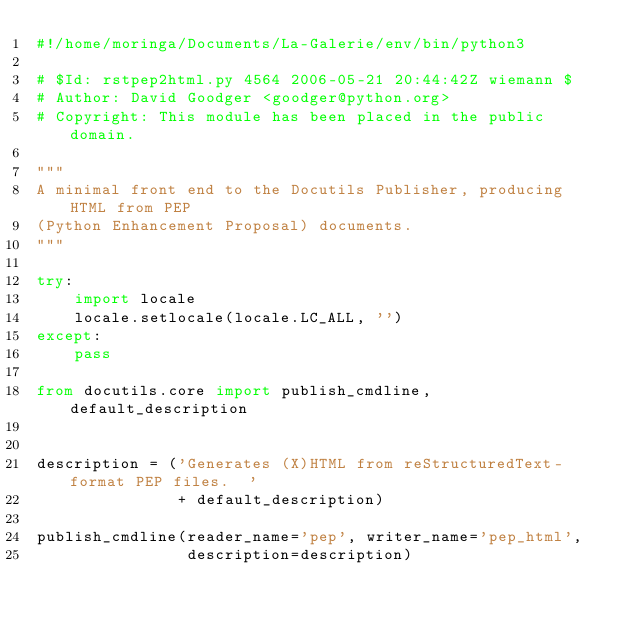Convert code to text. <code><loc_0><loc_0><loc_500><loc_500><_Python_>#!/home/moringa/Documents/La-Galerie/env/bin/python3

# $Id: rstpep2html.py 4564 2006-05-21 20:44:42Z wiemann $
# Author: David Goodger <goodger@python.org>
# Copyright: This module has been placed in the public domain.

"""
A minimal front end to the Docutils Publisher, producing HTML from PEP
(Python Enhancement Proposal) documents.
"""

try:
    import locale
    locale.setlocale(locale.LC_ALL, '')
except:
    pass

from docutils.core import publish_cmdline, default_description


description = ('Generates (X)HTML from reStructuredText-format PEP files.  '
               + default_description)

publish_cmdline(reader_name='pep', writer_name='pep_html',
                description=description)
</code> 